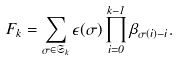<formula> <loc_0><loc_0><loc_500><loc_500>F _ { k } = \sum _ { \sigma \in \mathfrak S _ { k } } \epsilon ( \sigma ) \prod _ { i = 0 } ^ { k - 1 } \beta _ { \sigma ( i ) - i } .</formula> 